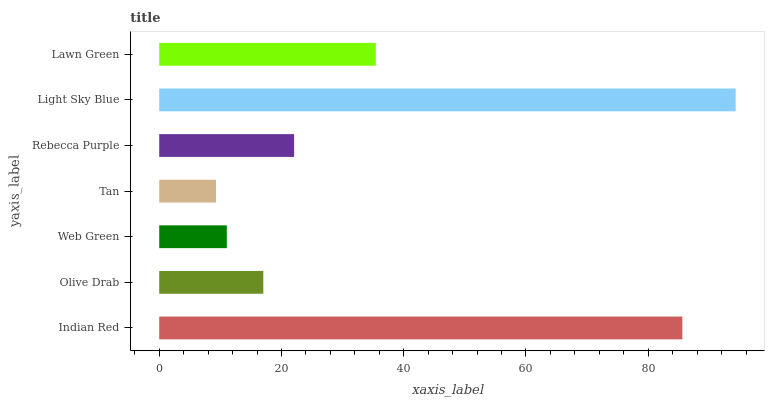Is Tan the minimum?
Answer yes or no. Yes. Is Light Sky Blue the maximum?
Answer yes or no. Yes. Is Olive Drab the minimum?
Answer yes or no. No. Is Olive Drab the maximum?
Answer yes or no. No. Is Indian Red greater than Olive Drab?
Answer yes or no. Yes. Is Olive Drab less than Indian Red?
Answer yes or no. Yes. Is Olive Drab greater than Indian Red?
Answer yes or no. No. Is Indian Red less than Olive Drab?
Answer yes or no. No. Is Rebecca Purple the high median?
Answer yes or no. Yes. Is Rebecca Purple the low median?
Answer yes or no. Yes. Is Olive Drab the high median?
Answer yes or no. No. Is Olive Drab the low median?
Answer yes or no. No. 